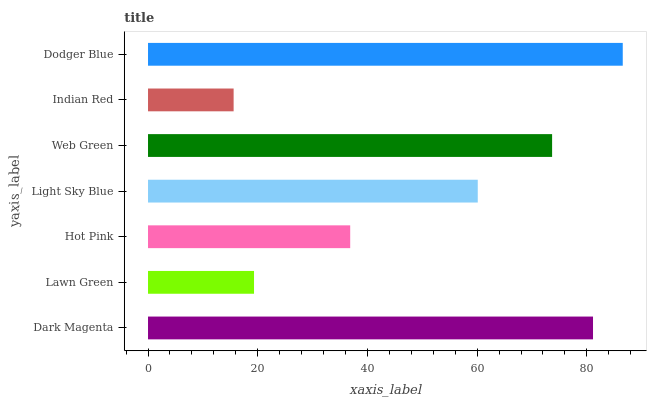Is Indian Red the minimum?
Answer yes or no. Yes. Is Dodger Blue the maximum?
Answer yes or no. Yes. Is Lawn Green the minimum?
Answer yes or no. No. Is Lawn Green the maximum?
Answer yes or no. No. Is Dark Magenta greater than Lawn Green?
Answer yes or no. Yes. Is Lawn Green less than Dark Magenta?
Answer yes or no. Yes. Is Lawn Green greater than Dark Magenta?
Answer yes or no. No. Is Dark Magenta less than Lawn Green?
Answer yes or no. No. Is Light Sky Blue the high median?
Answer yes or no. Yes. Is Light Sky Blue the low median?
Answer yes or no. Yes. Is Dark Magenta the high median?
Answer yes or no. No. Is Lawn Green the low median?
Answer yes or no. No. 